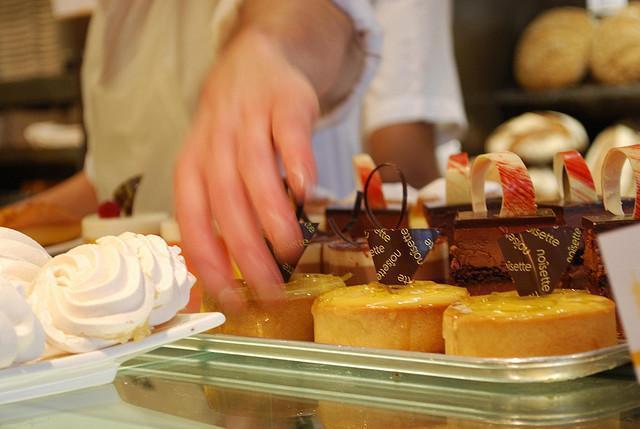How many cakes can be seen?
Give a very brief answer. 7. How many donuts are in the picture?
Give a very brief answer. 3. How many trains do you see?
Give a very brief answer. 0. 